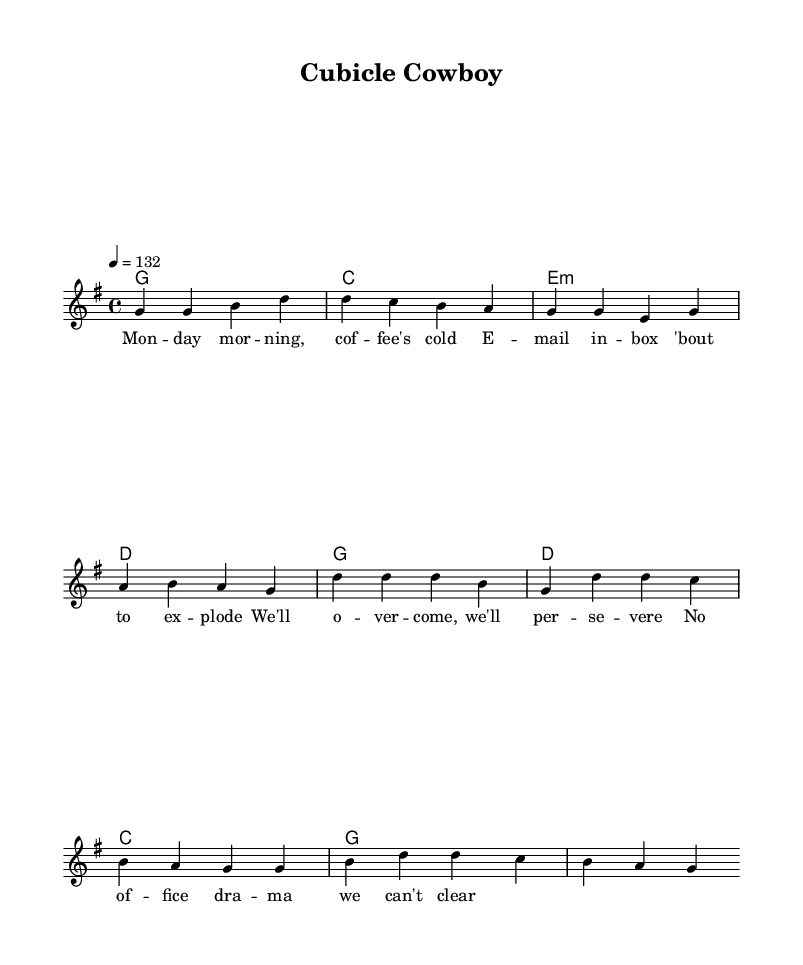What is the key signature of this music? The key signature is G major, indicated by one sharp (F#). This can be identified in the global settings of the music, which shows the key signature used throughout the piece.
Answer: G major What is the time signature of this music? The time signature is 4/4, as indicated in the global settings at the beginning of the music. It shows that there are four beats in each measure.
Answer: 4/4 What is the tempo of this music? The tempo is 132 beats per minute, provided in the global settings. It specifies the speed at which the music should be played.
Answer: 132 How many measures are in the verse? The verse consists of four measures, which can be counted from the melody section where the notes are grouped. Each vertical line (bar line) represents the end of a measure.
Answer: Four What are the primary chords used in the chorus? The primary chords in the chorus are G, D, C, and G. These chords are indicated in the chord mode section of the score where the chorus chords are listed.
Answer: G, D, C, G What message is conveyed in the lyrics of the verse? The lyrics describe the scenario of a stressful Monday morning at work, capturing the emotional landscape of dealing with workplace challenges. Analyzing the words provides insight into the underlying theme of overcoming difficulties.
Answer: Workplace stress What is the main theme of the song? The main theme centers around overcoming workplace challenges and drama, as reflected in the lyrics and overall energetic feel of the country rock tune. This theme is essential to the narrative conveyed through both the lyrics and the music style.
Answer: Overcoming workplace challenges 